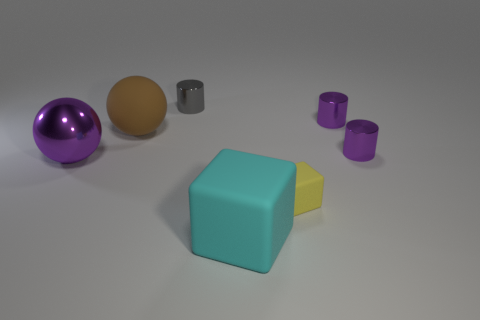There is a matte thing that is to the left of the large thing in front of the yellow matte block behind the large cyan object; what is its color?
Ensure brevity in your answer.  Brown. Do the yellow matte cube and the shiny cylinder to the left of the small cube have the same size?
Offer a very short reply. Yes. What number of things are either gray metallic cylinders or tiny purple metal things?
Make the answer very short. 3. Are there any cyan cubes made of the same material as the yellow thing?
Provide a short and direct response. Yes. There is a small metallic cylinder that is to the left of the block that is in front of the tiny yellow cube; what color is it?
Your answer should be compact. Gray. Is the size of the cyan block the same as the purple metal ball?
Your answer should be compact. Yes. What number of spheres are small shiny objects or green objects?
Your response must be concise. 0. How many tiny objects are to the left of the rubber cube right of the cyan rubber cube?
Make the answer very short. 1. Is the tiny yellow matte thing the same shape as the cyan rubber thing?
Provide a short and direct response. Yes. There is a purple thing that is the same shape as the big brown matte thing; what size is it?
Keep it short and to the point. Large. 